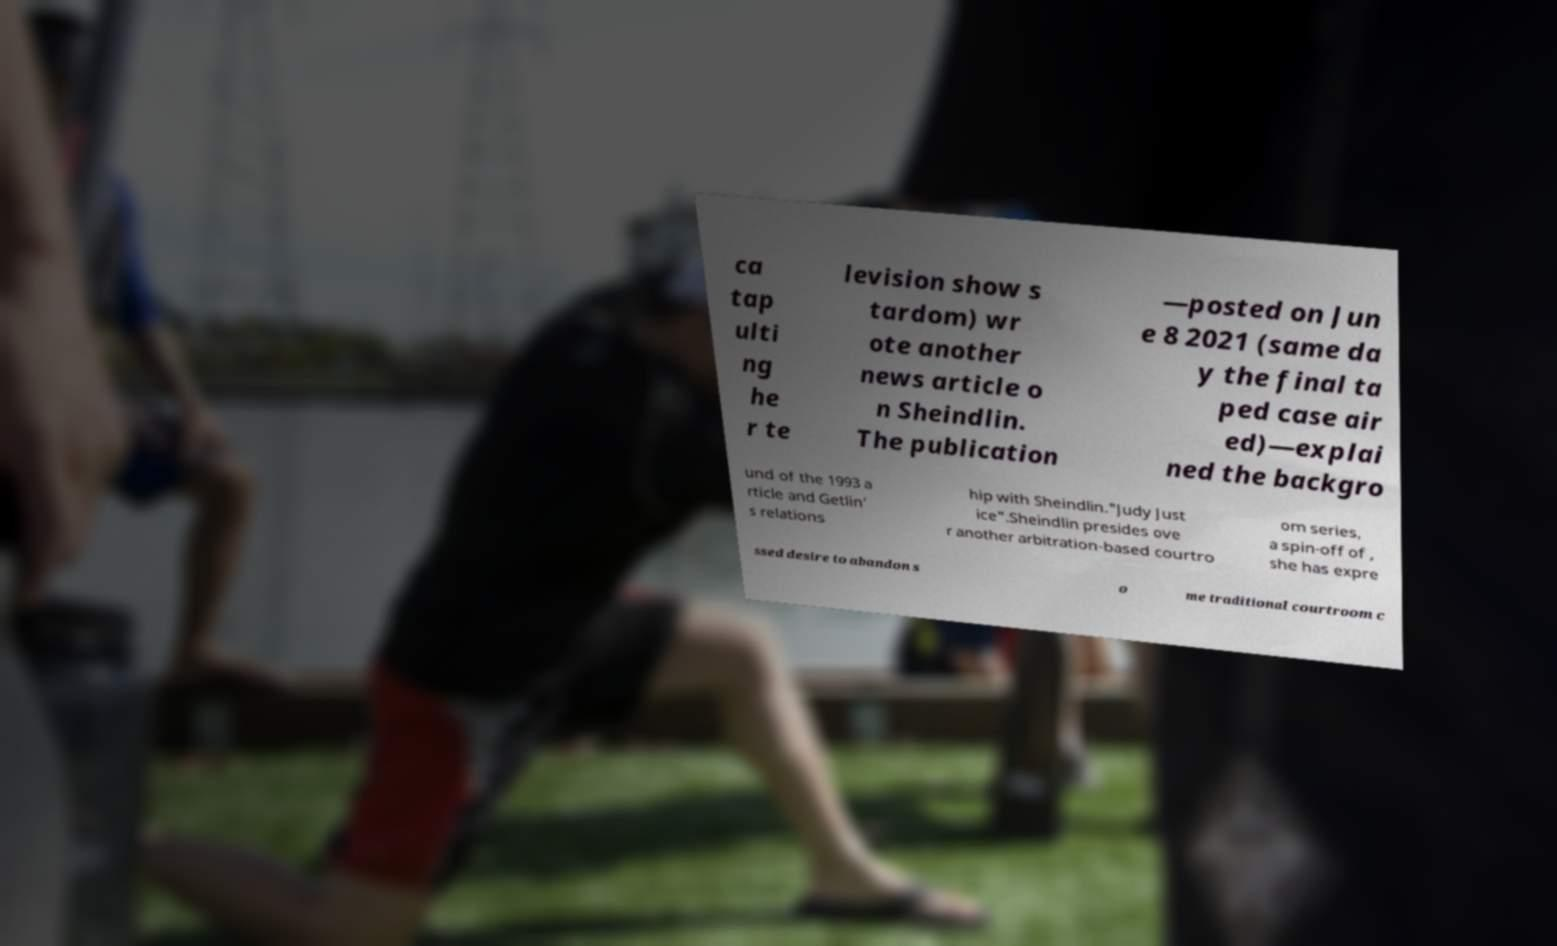There's text embedded in this image that I need extracted. Can you transcribe it verbatim? ca tap ulti ng he r te levision show s tardom) wr ote another news article o n Sheindlin. The publication —posted on Jun e 8 2021 (same da y the final ta ped case air ed)—explai ned the backgro und of the 1993 a rticle and Getlin' s relations hip with Sheindlin."Judy Just ice".Sheindlin presides ove r another arbitration-based courtro om series, a spin-off of , she has expre ssed desire to abandon s o me traditional courtroom c 